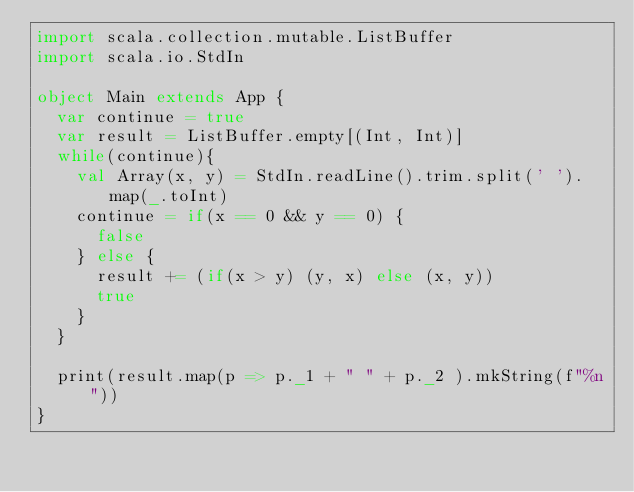Convert code to text. <code><loc_0><loc_0><loc_500><loc_500><_Scala_>import scala.collection.mutable.ListBuffer
import scala.io.StdIn

object Main extends App {
  var continue = true
  var result = ListBuffer.empty[(Int, Int)]
  while(continue){
    val Array(x, y) = StdIn.readLine().trim.split(' ').map(_.toInt)
    continue = if(x == 0 && y == 0) {
      false
    } else {
      result += (if(x > y) (y, x) else (x, y))
      true
    }
  }
  
  print(result.map(p => p._1 + " " + p._2 ).mkString(f"%n"))
}
</code> 